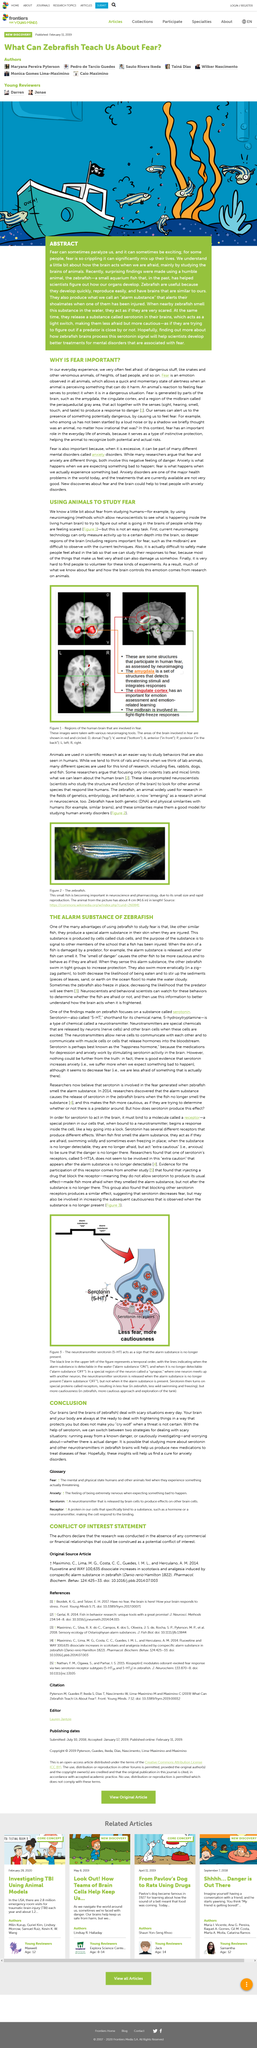Identify some key points in this picture. It is necessary to study fear in humans in order to truly understand the subject. The article refers to fish. The brain areas that are involved in fear include the amygdala, the cingulate cortex, and the midbrain. Animals are used in scientific research as an easier way to study behaviors that are also seen in humans. It is challenging to conduct research on fear due to the difficulty in inducing fear in participants in a controlled and safe manner. 